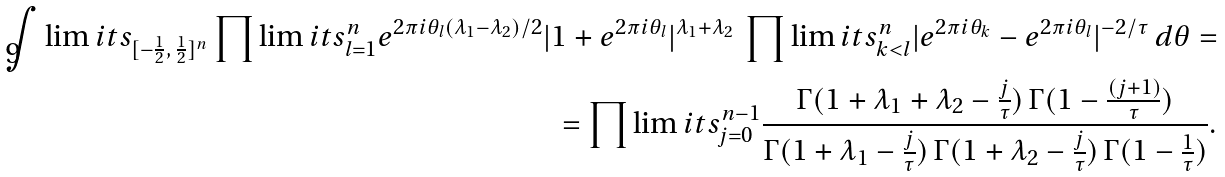Convert formula to latex. <formula><loc_0><loc_0><loc_500><loc_500>\int \lim i t s _ { [ - \frac { 1 } { 2 } , \, \frac { 1 } { 2 } ] ^ { n } } \prod \lim i t s _ { l = 1 } ^ { n } e ^ { 2 \pi i \theta _ { l } ( \lambda _ { 1 } - \lambda _ { 2 } ) / 2 } | 1 + e ^ { 2 \pi i \theta _ { l } } | ^ { \lambda _ { 1 } + \lambda _ { 2 } } \, \prod \lim i t s _ { k < l } ^ { n } | e ^ { 2 \pi i \theta _ { k } } - e ^ { 2 \pi i \theta _ { l } } | ^ { - 2 / \tau } \, d \theta = \\ = \prod \lim i t s _ { j = 0 } ^ { n - 1 } \frac { \Gamma ( 1 + \lambda _ { 1 } + \lambda _ { 2 } - \frac { j } { \tau } ) \, \Gamma ( 1 - \frac { ( j + 1 ) } { \tau } ) } { \Gamma ( 1 + \lambda _ { 1 } - \frac { j } { \tau } ) \, \Gamma ( 1 + \lambda _ { 2 } - \frac { j } { \tau } ) \, \Gamma ( 1 - \frac { 1 } { \tau } ) } .</formula> 